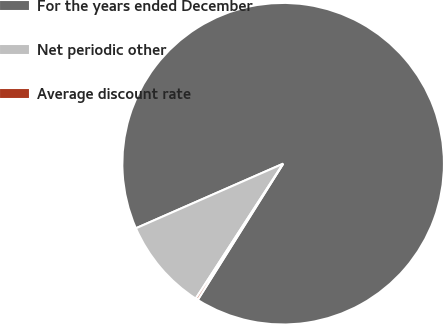<chart> <loc_0><loc_0><loc_500><loc_500><pie_chart><fcel>For the years ended December<fcel>Net periodic other<fcel>Average discount rate<nl><fcel>90.49%<fcel>9.27%<fcel>0.24%<nl></chart> 